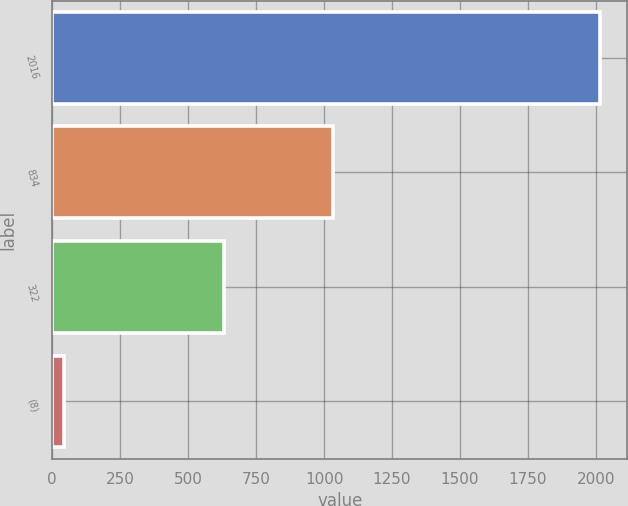Convert chart. <chart><loc_0><loc_0><loc_500><loc_500><bar_chart><fcel>2016<fcel>834<fcel>322<fcel>(8)<nl><fcel>2015<fcel>1033<fcel>633<fcel>44<nl></chart> 